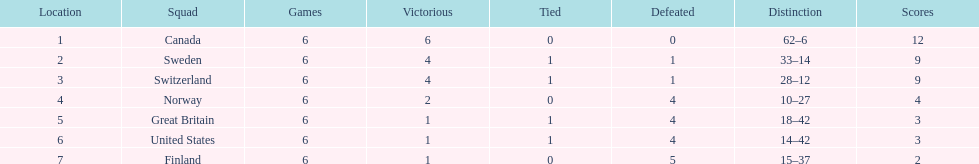Which country finished below the united states? Finland. 